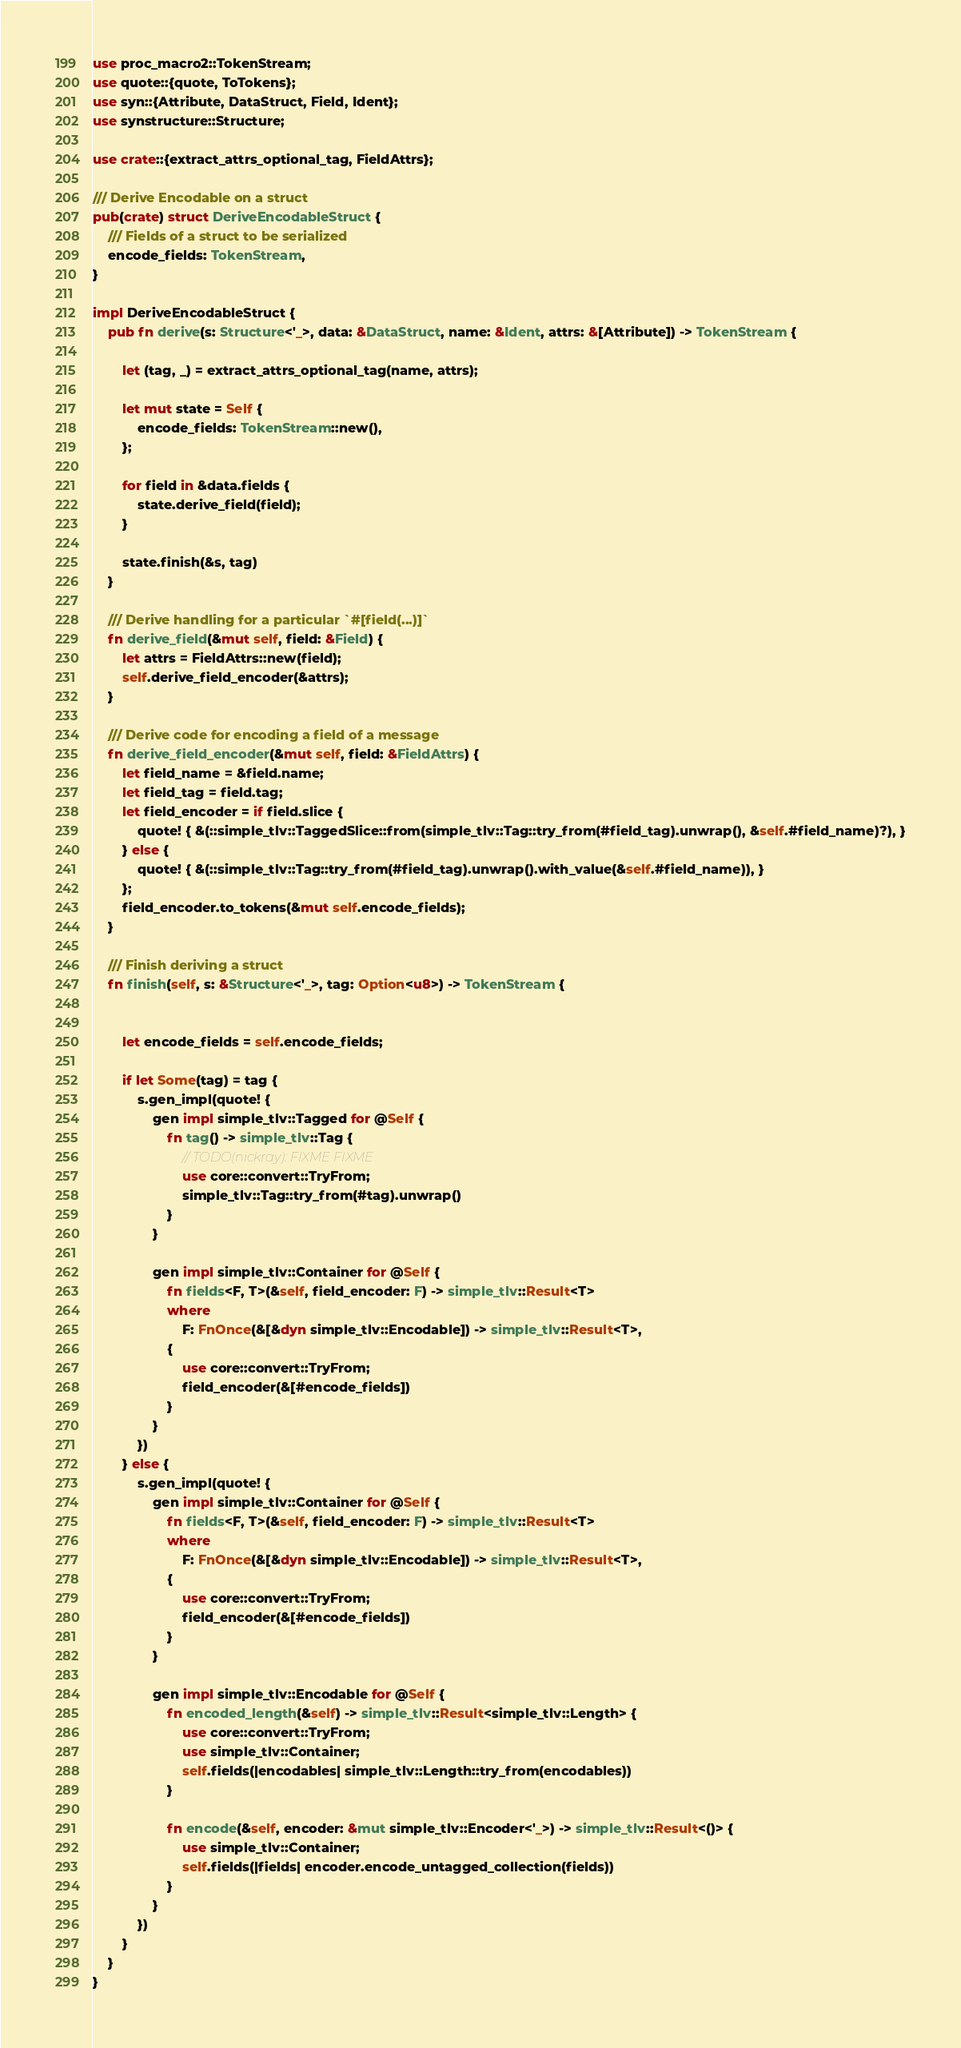Convert code to text. <code><loc_0><loc_0><loc_500><loc_500><_Rust_>use proc_macro2::TokenStream;
use quote::{quote, ToTokens};
use syn::{Attribute, DataStruct, Field, Ident};
use synstructure::Structure;

use crate::{extract_attrs_optional_tag, FieldAttrs};

/// Derive Encodable on a struct
pub(crate) struct DeriveEncodableStruct {
    /// Fields of a struct to be serialized
    encode_fields: TokenStream,
}

impl DeriveEncodableStruct {
    pub fn derive(s: Structure<'_>, data: &DataStruct, name: &Ident, attrs: &[Attribute]) -> TokenStream {

        let (tag, _) = extract_attrs_optional_tag(name, attrs);

        let mut state = Self {
            encode_fields: TokenStream::new(),
        };

        for field in &data.fields {
            state.derive_field(field);
        }

        state.finish(&s, tag)
    }

    /// Derive handling for a particular `#[field(...)]`
    fn derive_field(&mut self, field: &Field) {
        let attrs = FieldAttrs::new(field);
        self.derive_field_encoder(&attrs);
    }

    /// Derive code for encoding a field of a message
    fn derive_field_encoder(&mut self, field: &FieldAttrs) {
        let field_name = &field.name;
        let field_tag = field.tag;
        let field_encoder = if field.slice {
            quote! { &(::simple_tlv::TaggedSlice::from(simple_tlv::Tag::try_from(#field_tag).unwrap(), &self.#field_name)?), }
        } else {
            quote! { &(::simple_tlv::Tag::try_from(#field_tag).unwrap().with_value(&self.#field_name)), }
        };
        field_encoder.to_tokens(&mut self.encode_fields);
    }

    /// Finish deriving a struct
    fn finish(self, s: &Structure<'_>, tag: Option<u8>) -> TokenStream {


        let encode_fields = self.encode_fields;

        if let Some(tag) = tag {
            s.gen_impl(quote! {
                gen impl simple_tlv::Tagged for @Self {
                    fn tag() -> simple_tlv::Tag {
                        // TODO(nickray): FIXME FIXME
                        use core::convert::TryFrom;
                        simple_tlv::Tag::try_from(#tag).unwrap()
                    }
                }

                gen impl simple_tlv::Container for @Self {
                    fn fields<F, T>(&self, field_encoder: F) -> simple_tlv::Result<T>
                    where
                        F: FnOnce(&[&dyn simple_tlv::Encodable]) -> simple_tlv::Result<T>,
                    {
                        use core::convert::TryFrom;
                        field_encoder(&[#encode_fields])
                    }
                }
            })
        } else {
            s.gen_impl(quote! {
                gen impl simple_tlv::Container for @Self {
                    fn fields<F, T>(&self, field_encoder: F) -> simple_tlv::Result<T>
                    where
                        F: FnOnce(&[&dyn simple_tlv::Encodable]) -> simple_tlv::Result<T>,
                    {
                        use core::convert::TryFrom;
                        field_encoder(&[#encode_fields])
                    }
                }

                gen impl simple_tlv::Encodable for @Self {
                    fn encoded_length(&self) -> simple_tlv::Result<simple_tlv::Length> {
                        use core::convert::TryFrom;
                        use simple_tlv::Container;
                        self.fields(|encodables| simple_tlv::Length::try_from(encodables))
                    }

                    fn encode(&self, encoder: &mut simple_tlv::Encoder<'_>) -> simple_tlv::Result<()> {
                        use simple_tlv::Container;
                        self.fields(|fields| encoder.encode_untagged_collection(fields))
                    }
                }
            })
        }
    }
}

</code> 